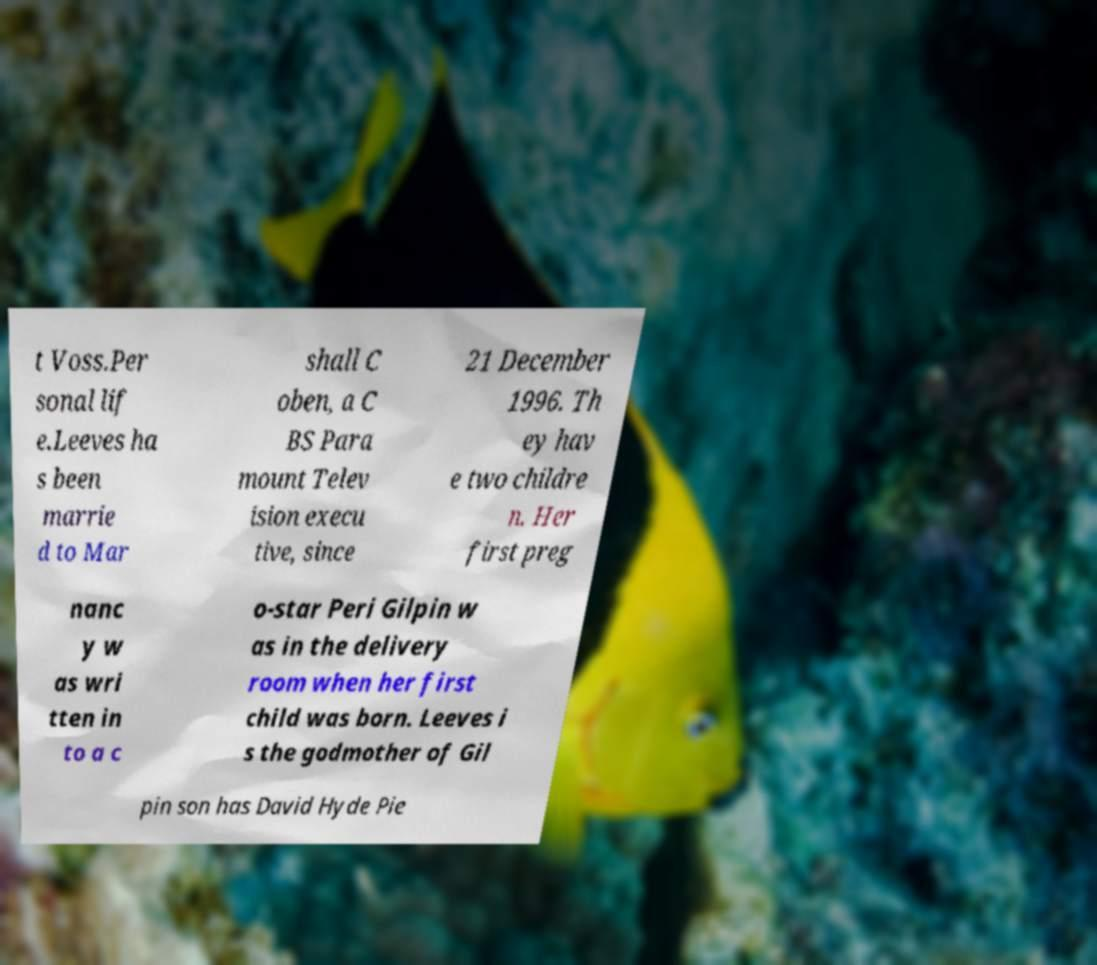Please read and relay the text visible in this image. What does it say? t Voss.Per sonal lif e.Leeves ha s been marrie d to Mar shall C oben, a C BS Para mount Telev ision execu tive, since 21 December 1996. Th ey hav e two childre n. Her first preg nanc y w as wri tten in to a c o-star Peri Gilpin w as in the delivery room when her first child was born. Leeves i s the godmother of Gil pin son has David Hyde Pie 